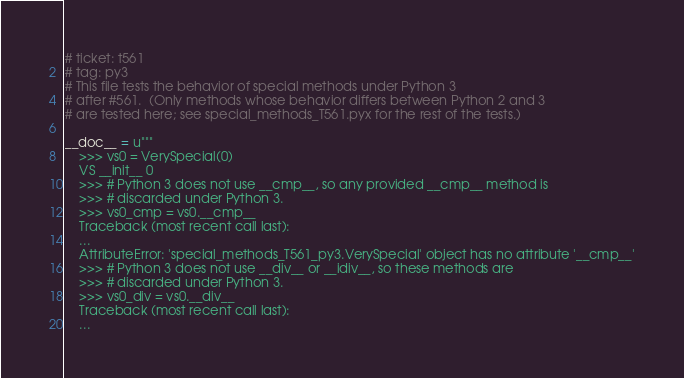<code> <loc_0><loc_0><loc_500><loc_500><_Cython_># ticket: t561
# tag: py3
# This file tests the behavior of special methods under Python 3
# after #561.  (Only methods whose behavior differs between Python 2 and 3
# are tested here; see special_methods_T561.pyx for the rest of the tests.)

__doc__ = u"""
    >>> vs0 = VerySpecial(0)
    VS __init__ 0
    >>> # Python 3 does not use __cmp__, so any provided __cmp__ method is
    >>> # discarded under Python 3.
    >>> vs0_cmp = vs0.__cmp__
    Traceback (most recent call last):
    ...
    AttributeError: 'special_methods_T561_py3.VerySpecial' object has no attribute '__cmp__'
    >>> # Python 3 does not use __div__ or __idiv__, so these methods are
    >>> # discarded under Python 3.
    >>> vs0_div = vs0.__div__
    Traceback (most recent call last):
    ...</code> 